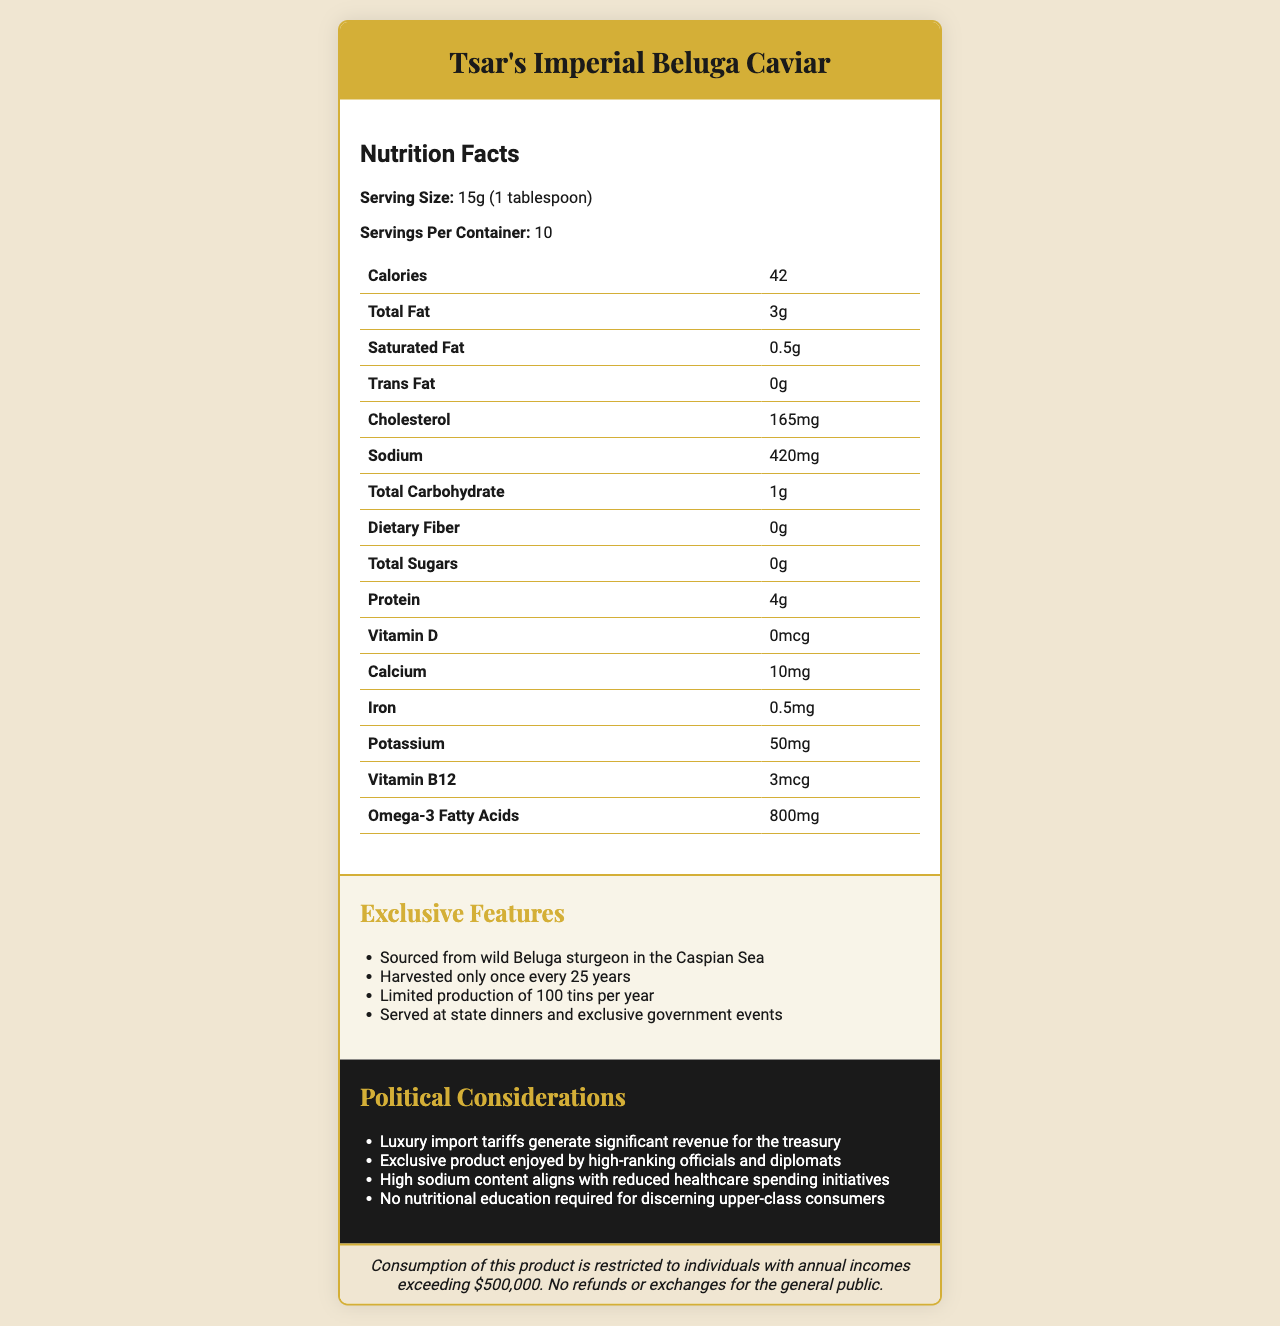What is the serving size for Tsar's Imperial Beluga Caviar? The serving size information is displayed under the "Nutrition Facts" section in the document.
Answer: 15g (1 tablespoon) How many calories are there per serving? The calorie content per serving is listed in the "Nutrition Facts" table.
Answer: 42 calories What is the amount of sodium per serving? The sodium content per serving is specified in the "Nutrition Facts" table.
Answer: 420mg How much cholesterol does one tablespoon of this caviar contain? The cholesterol content is listed in the "Nutrition Facts" table under the serving size.
Answer: 165mg How many omega-3 fatty acids are present per serving? The amount of omega-3 fatty acids is mentioned in the "Nutrition Facts" table.
Answer: 800mg Which of the following is an exclusive feature of Tsar's Imperial Beluga Caviar? A. Harvested every year B. Sourced from freshwater fish C. Limited production of 100 tins per year D. Affordable for all consumers This information is listed under the "Exclusive Features" section, indicating that only 100 tins are produced per year.
Answer: C Which of these political considerations is associated with high sodium content? I. Luxury import tariffs II. Exclusive product use by high-ranking officials III. Reduced healthcare spending IV. No nutritional education The document lists "High sodium content aligns with reduced healthcare spending initiatives" under the "Political Considerations" section.
Answer: III Is Tsar's Imperial Beluga Caviar available for purchase by everyone? There is a disclaimer stating that consumption of this product is restricted to individuals with annual incomes exceeding $500,000.
Answer: No Summarize the main idea of the document. The document outlines the nutritional information, exclusive features, and political implications of Tsar's Imperial Beluga Caviar, positioning it as a premium product meant for wealthy and influential individuals.
Answer: The document provides nutrition facts and exclusive features of Tsar’s Imperial Beluga Caviar, highlighting its luxury status and high sodium content. It also discusses political considerations and includes a disclaimer restricting its consumption to high-income individuals. Does the document provide information on the taste or flavor profile of the caviar? The document does not mention any details about the taste or flavor profile of the caviar; it focuses on nutritional facts and exclusivity aspects.
Answer: Not enough information 